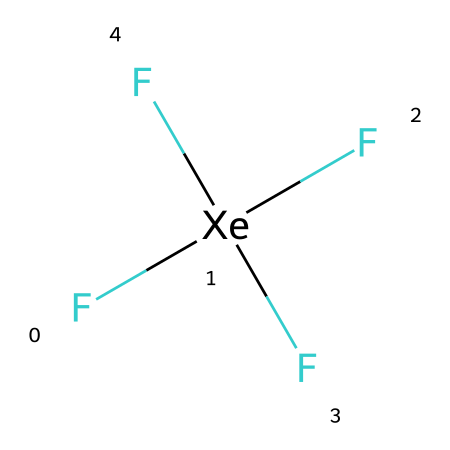How many fluorine atoms are present in this compound? The SMILES representation indicates that there are four fluorine atoms attached to the xenon atom, as denoted by the four occurrences of 'F' in the structure.
Answer: 4 What is the central atom in this chemical structure? In the provided SMILES, 'Xe' indicates that xenon is the central atom, surrounded by the fluorine atoms.
Answer: xenon How many total bonds are formed in xenon tetrafluoride? Each of the four fluorine atoms forms a single bond with the xenon atom, leading to a total of four bonds in the structure.
Answer: 4 What hybridization is exhibited by the central xenon atom? The bonding configuration with four bonds suggests that the xenon atom in xenon tetrafluoride undergoes sp3d hybridization to accommodate the bonding and lone pairs.
Answer: sp3d Does xenon tetrafluoride follow the octet rule? In xenon tetrafluoride, xenon has more than eight electrons in its valence shell due to the four bonds with fluorine, indicating it does not follow the octet rule.
Answer: no What type of compound is xenon tetrafluoride classified as? Given its structure and bonding configuration, xenon tetrafluoride is classified as a hypervalent compound, as it has more than eight valence electrons around the central atom.
Answer: hypervalent 